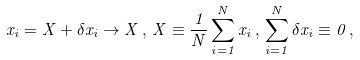<formula> <loc_0><loc_0><loc_500><loc_500>x _ { i } = X + \delta x _ { i } \rightarrow X \, , \, X \equiv \frac { 1 } { N } \sum _ { i = 1 } ^ { N } x _ { i } \, , \, \sum _ { i = 1 } ^ { N } \delta x _ { i } \equiv 0 \, ,</formula> 